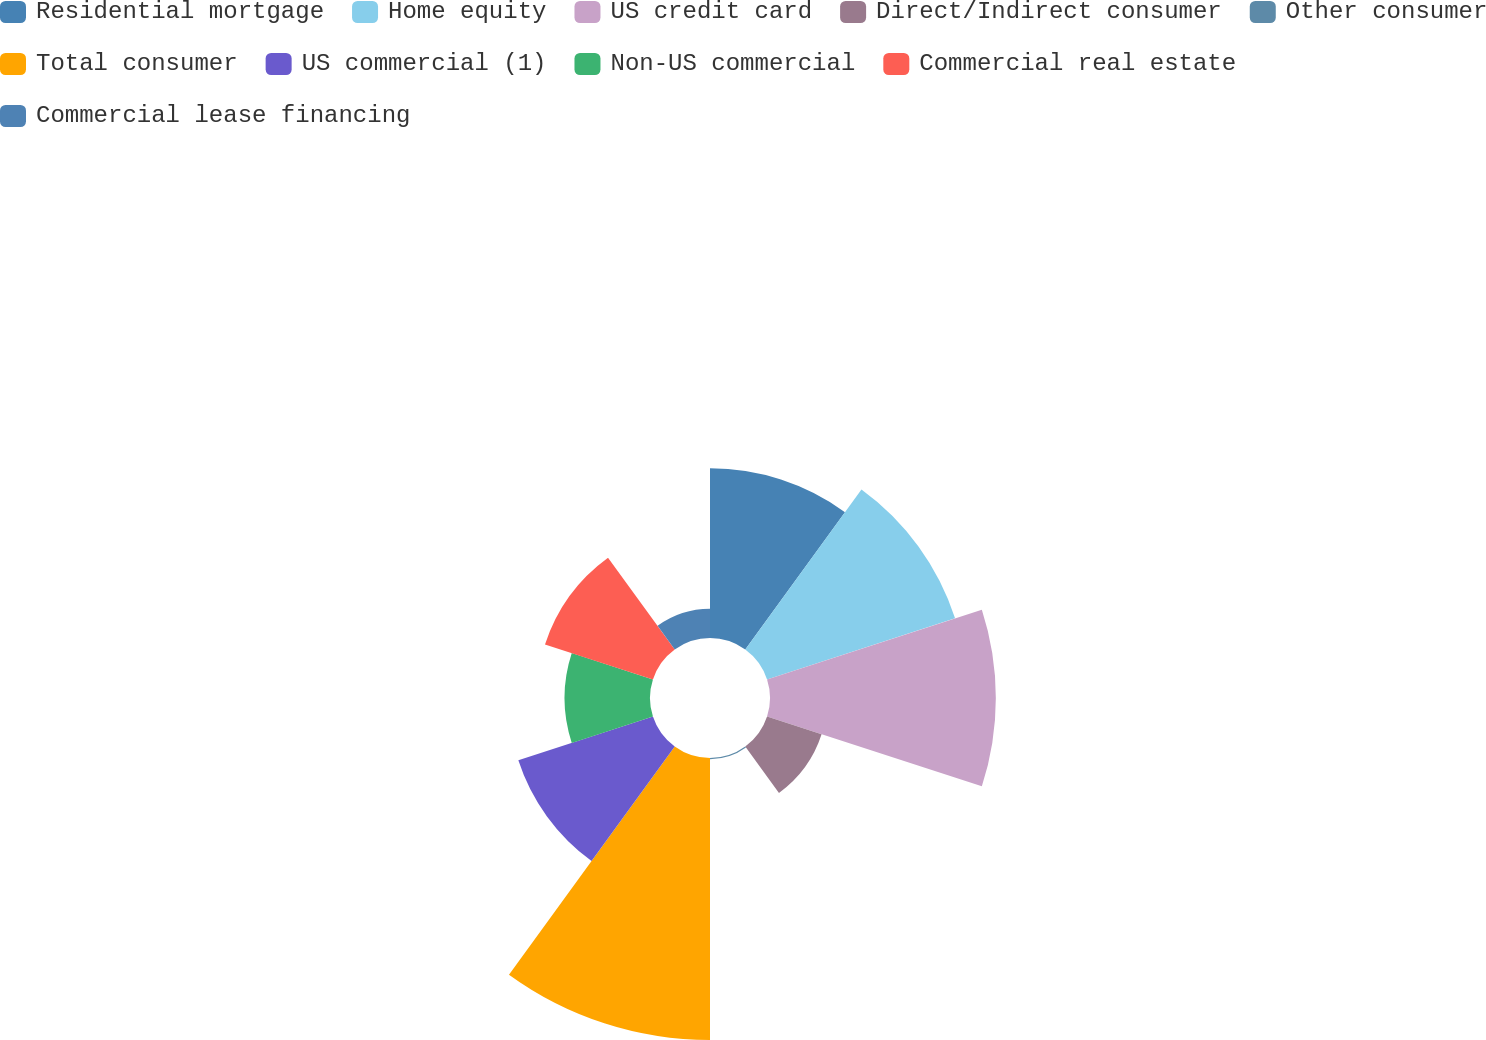Convert chart. <chart><loc_0><loc_0><loc_500><loc_500><pie_chart><fcel>Residential mortgage<fcel>Home equity<fcel>US credit card<fcel>Direct/Indirect consumer<fcel>Other consumer<fcel>Total consumer<fcel>US commercial (1)<fcel>Non-US commercial<fcel>Commercial real estate<fcel>Commercial lease financing<nl><fcel>13.02%<fcel>15.17%<fcel>17.33%<fcel>4.4%<fcel>0.09%<fcel>21.64%<fcel>10.86%<fcel>6.55%<fcel>8.71%<fcel>2.24%<nl></chart> 